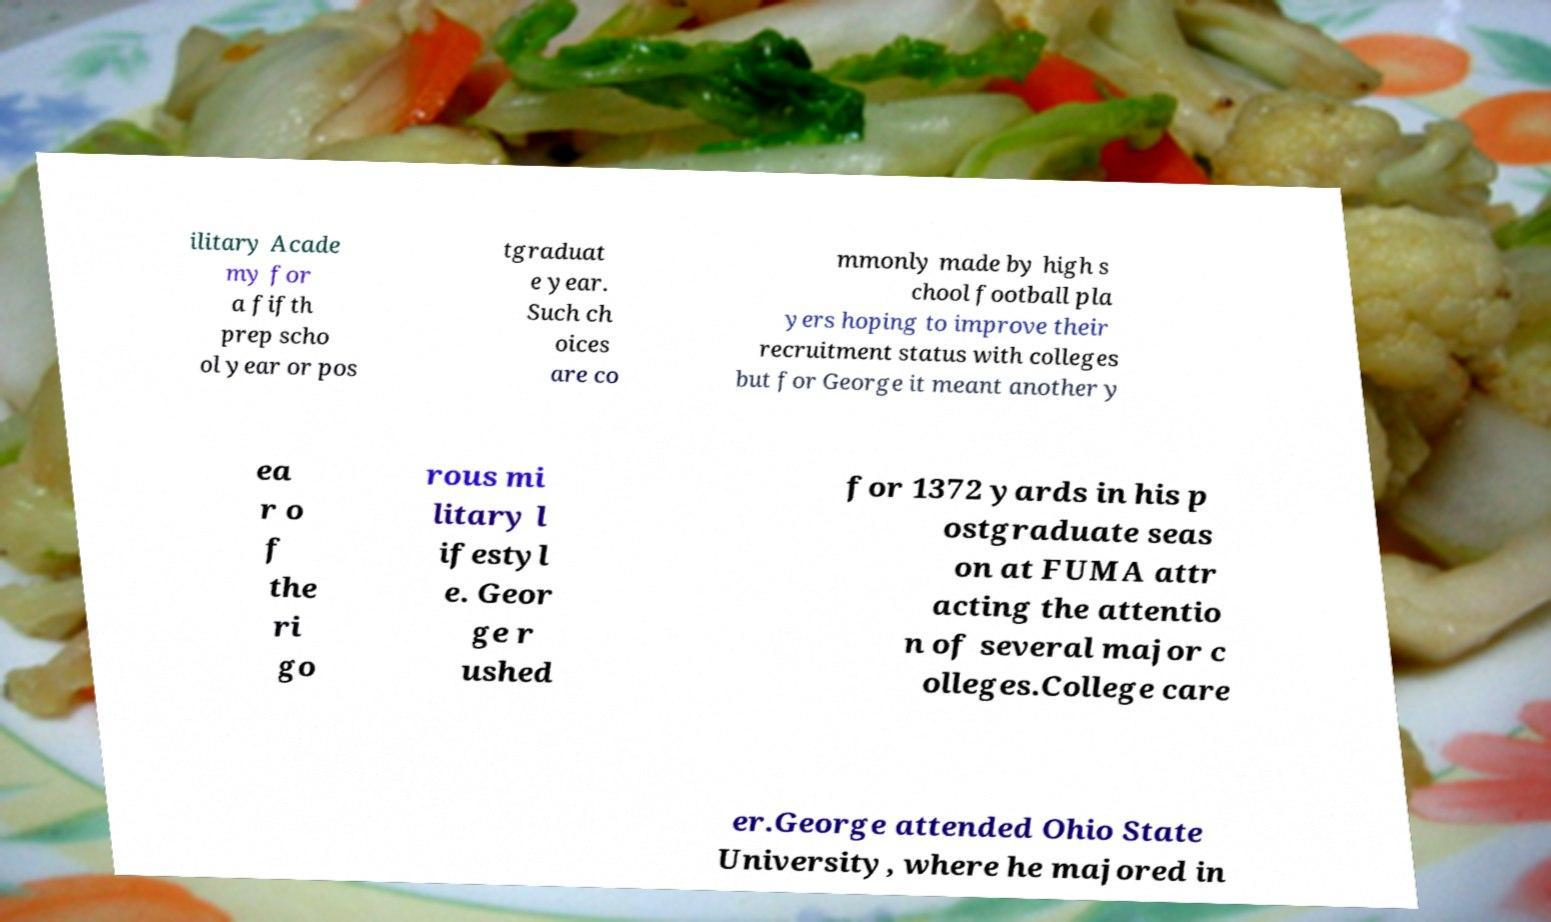There's text embedded in this image that I need extracted. Can you transcribe it verbatim? ilitary Acade my for a fifth prep scho ol year or pos tgraduat e year. Such ch oices are co mmonly made by high s chool football pla yers hoping to improve their recruitment status with colleges but for George it meant another y ea r o f the ri go rous mi litary l ifestyl e. Geor ge r ushed for 1372 yards in his p ostgraduate seas on at FUMA attr acting the attentio n of several major c olleges.College care er.George attended Ohio State University, where he majored in 